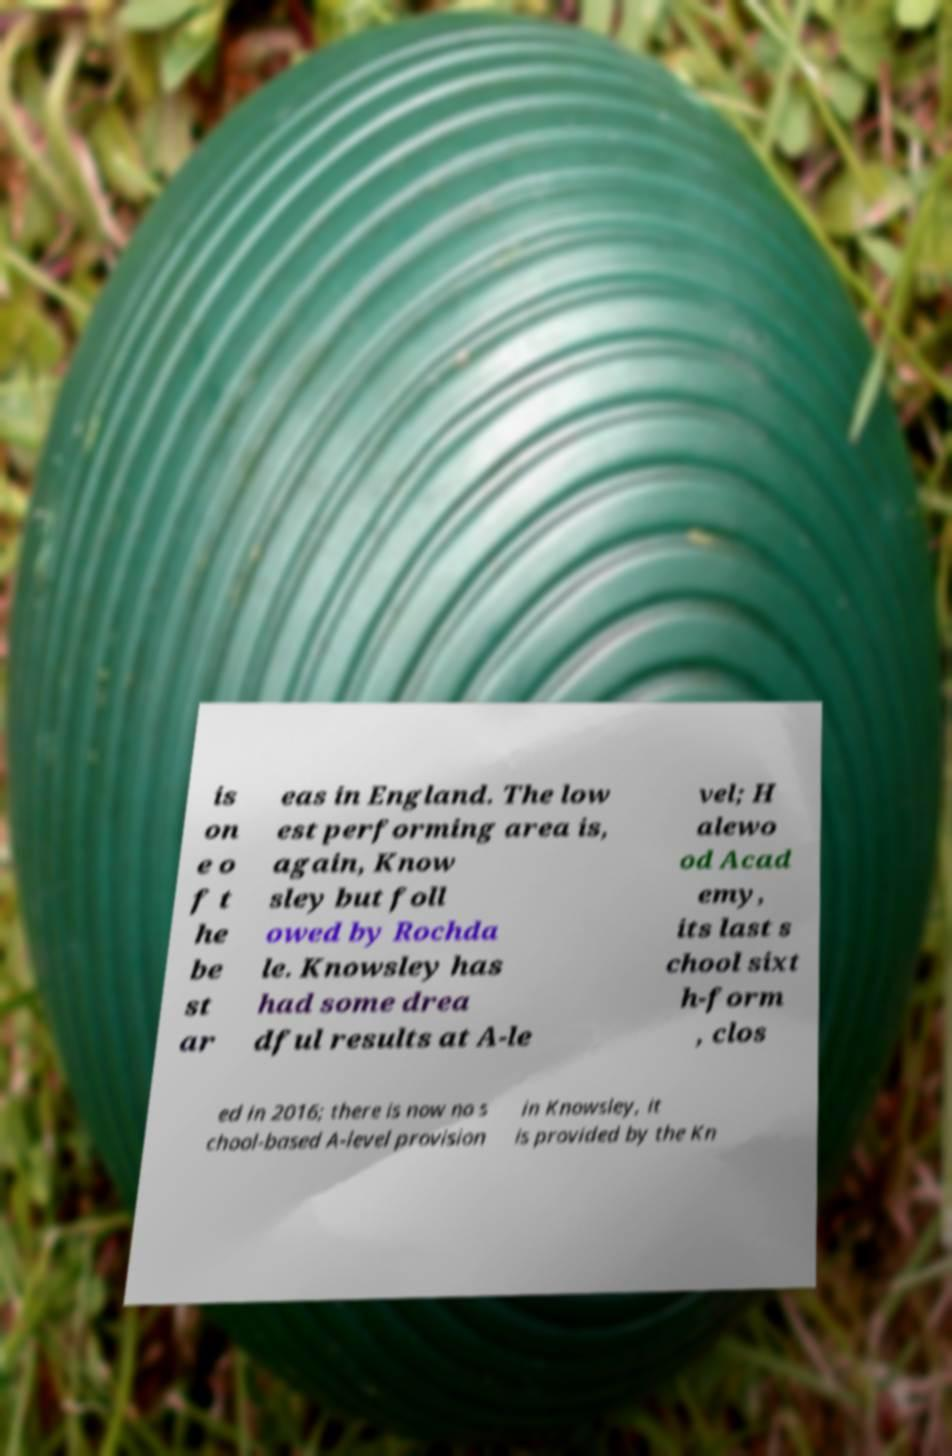Please read and relay the text visible in this image. What does it say? is on e o f t he be st ar eas in England. The low est performing area is, again, Know sley but foll owed by Rochda le. Knowsley has had some drea dful results at A-le vel; H alewo od Acad emy, its last s chool sixt h-form , clos ed in 2016; there is now no s chool-based A-level provision in Knowsley, it is provided by the Kn 